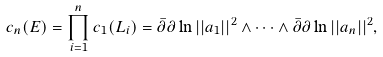<formula> <loc_0><loc_0><loc_500><loc_500>c _ { n } ( E ) = \prod _ { i = 1 } ^ { n } c _ { 1 } ( L _ { i } ) = \bar { \partial } \partial \ln | | a _ { 1 } | | ^ { 2 } \wedge \cdots \wedge \bar { \partial } \partial \ln | | a _ { n } | | ^ { 2 } ,</formula> 